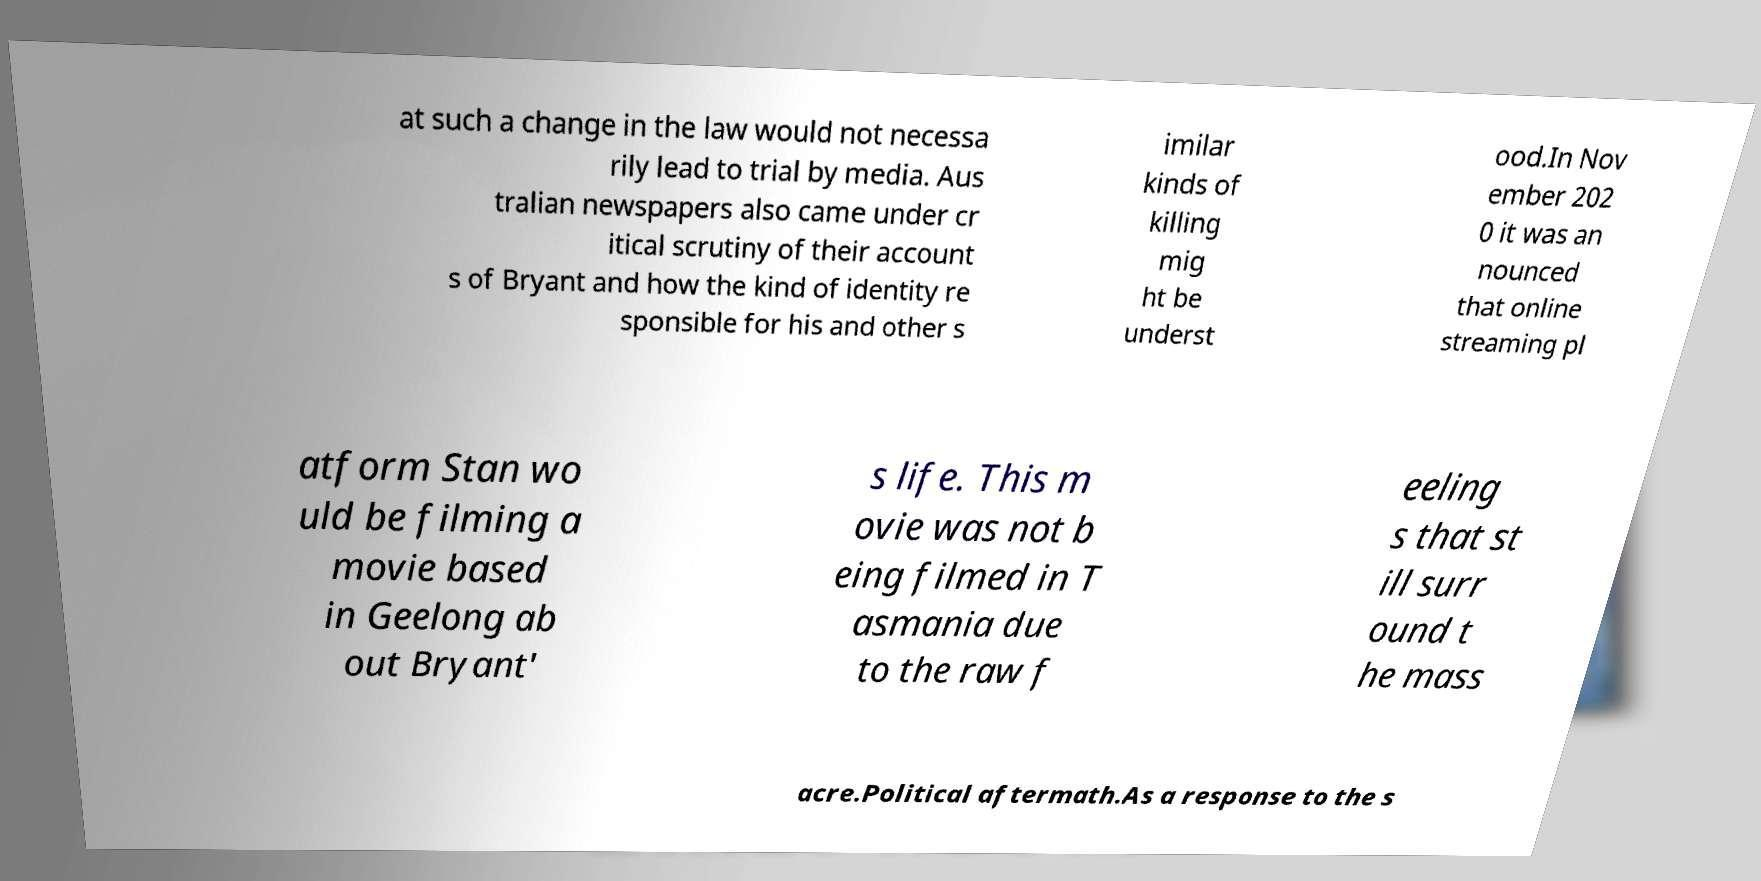What messages or text are displayed in this image? I need them in a readable, typed format. at such a change in the law would not necessa rily lead to trial by media. Aus tralian newspapers also came under cr itical scrutiny of their account s of Bryant and how the kind of identity re sponsible for his and other s imilar kinds of killing mig ht be underst ood.In Nov ember 202 0 it was an nounced that online streaming pl atform Stan wo uld be filming a movie based in Geelong ab out Bryant' s life. This m ovie was not b eing filmed in T asmania due to the raw f eeling s that st ill surr ound t he mass acre.Political aftermath.As a response to the s 